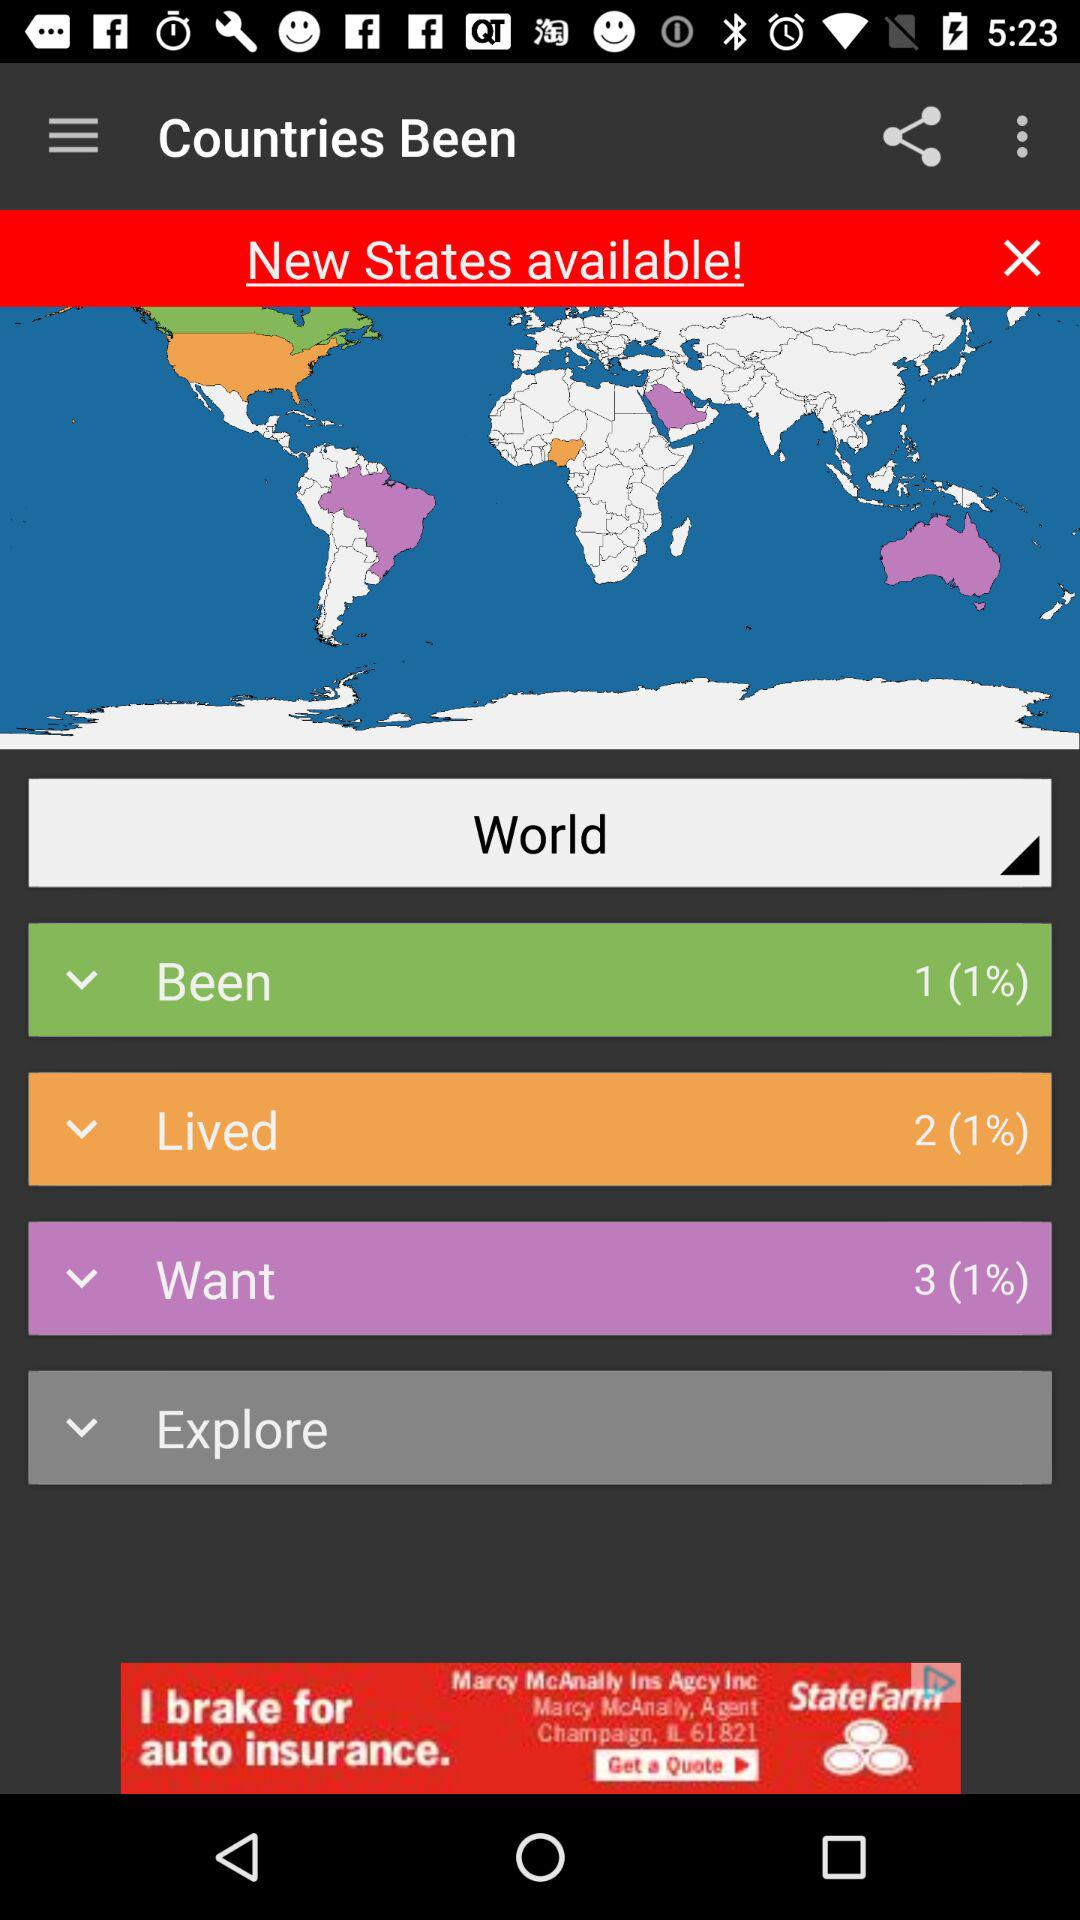What is the percentage of countries we have been to? The percentage of countries you have been to is 1. 